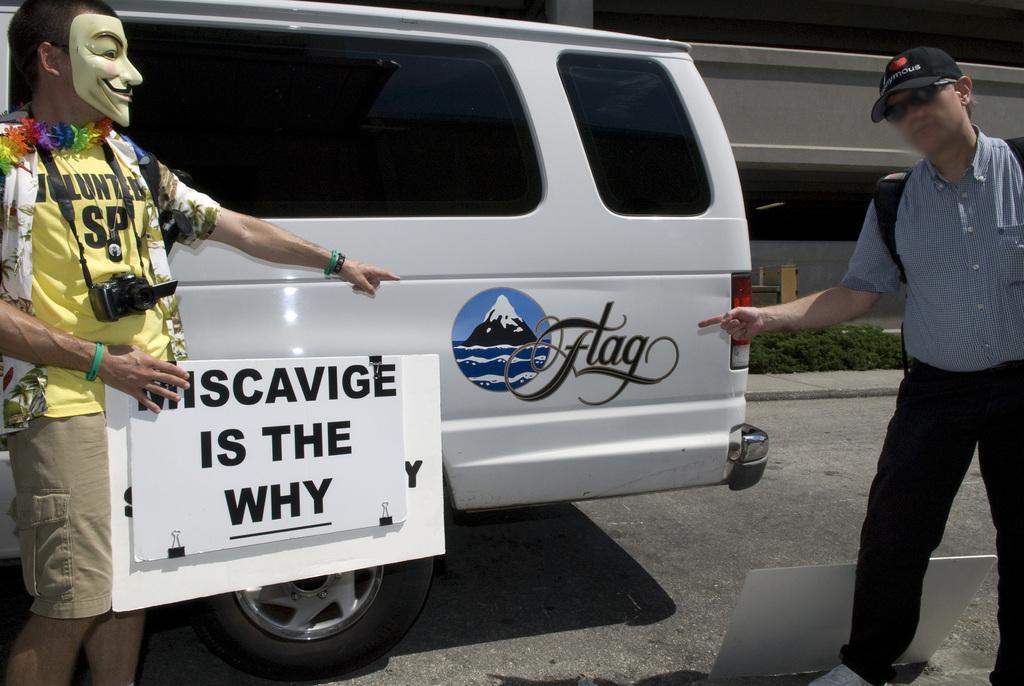What van company is being pointed at?
Ensure brevity in your answer.  Flag. What does the guy with the mask's sign say?
Provide a short and direct response. Miscavige is the why. 